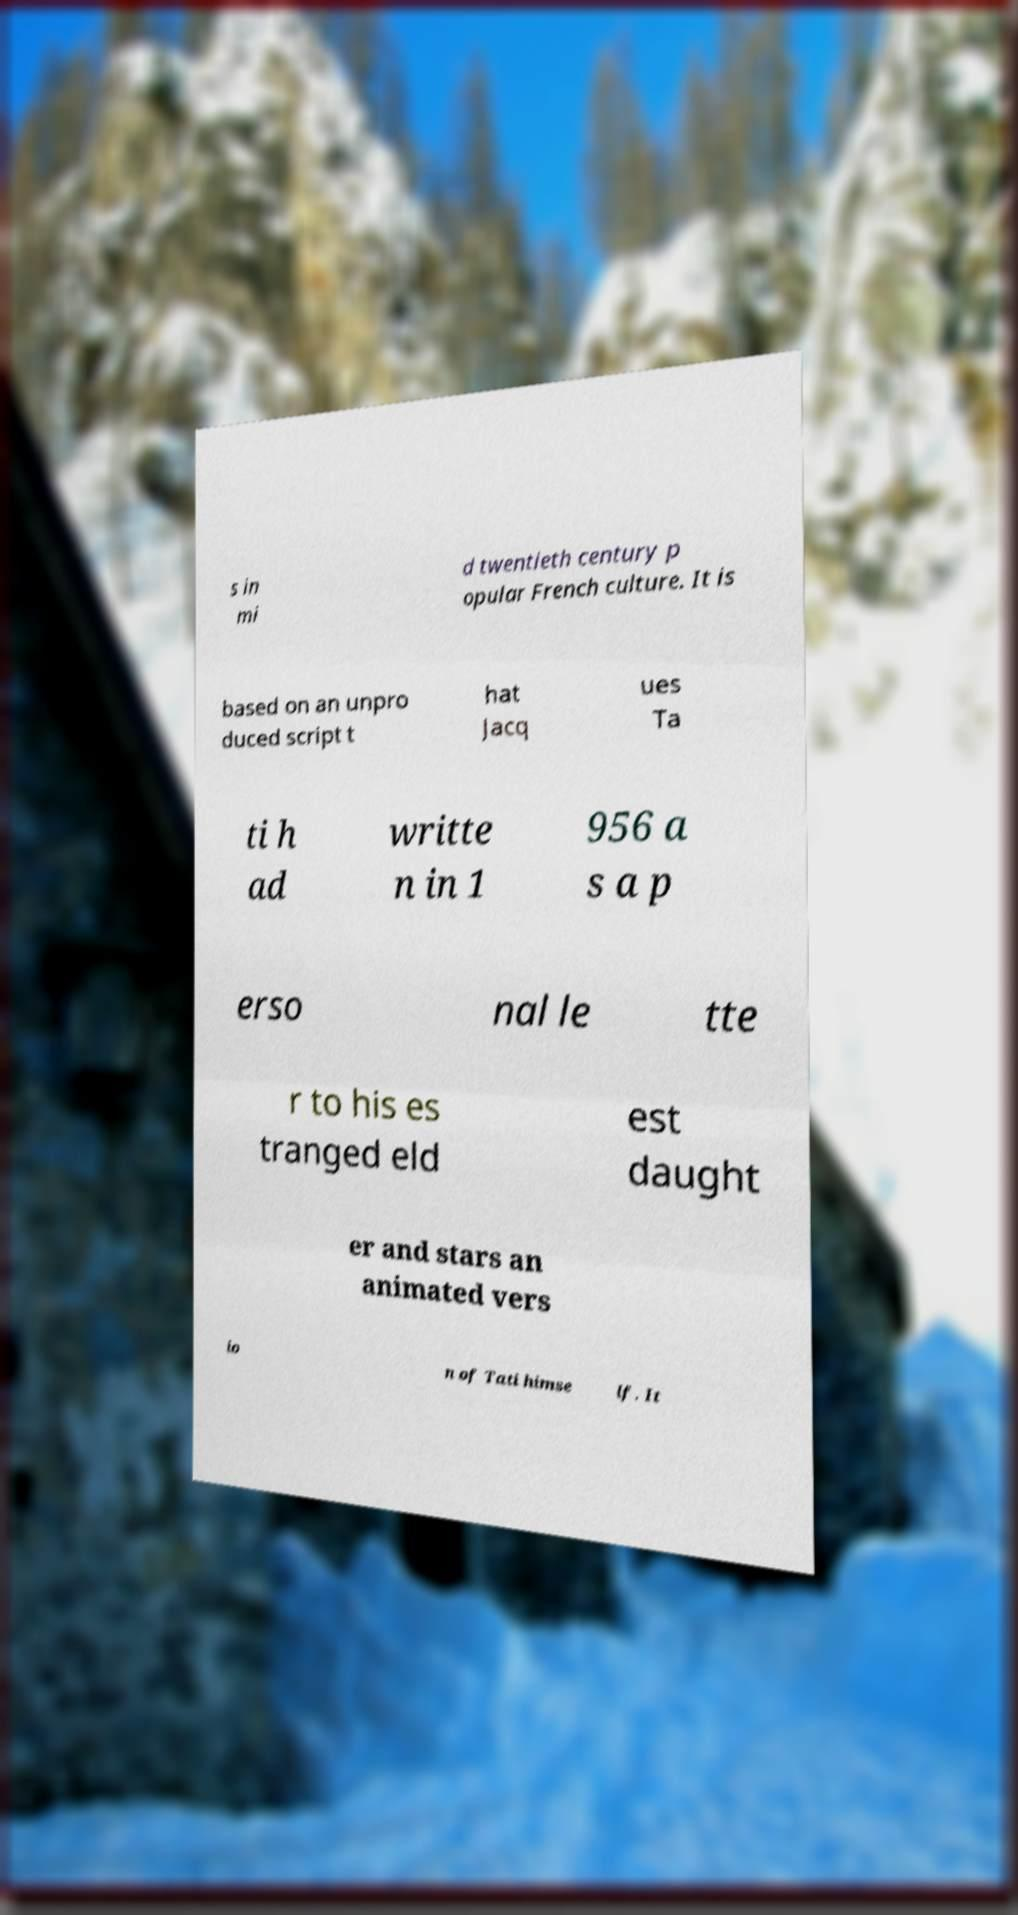Can you accurately transcribe the text from the provided image for me? s in mi d twentieth century p opular French culture. It is based on an unpro duced script t hat Jacq ues Ta ti h ad writte n in 1 956 a s a p erso nal le tte r to his es tranged eld est daught er and stars an animated vers io n of Tati himse lf. It 